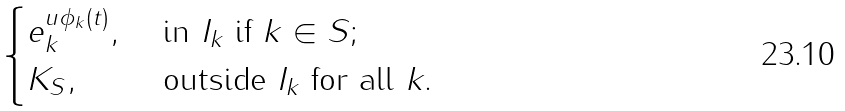Convert formula to latex. <formula><loc_0><loc_0><loc_500><loc_500>\begin{cases} e _ { k } ^ { u \phi _ { k } ( t ) } , & \text { in $I_{k}$ if $k\in S$; } \\ K _ { S } , & \text { outside $I_{k}$ for all $k$. } \end{cases}</formula> 